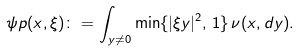Convert formula to latex. <formula><loc_0><loc_0><loc_500><loc_500>\psi p ( x , \xi ) \colon = \int _ { y \neq 0 } \min \{ | \xi y | ^ { 2 } , \, 1 \} \, \nu ( x , d y ) .</formula> 